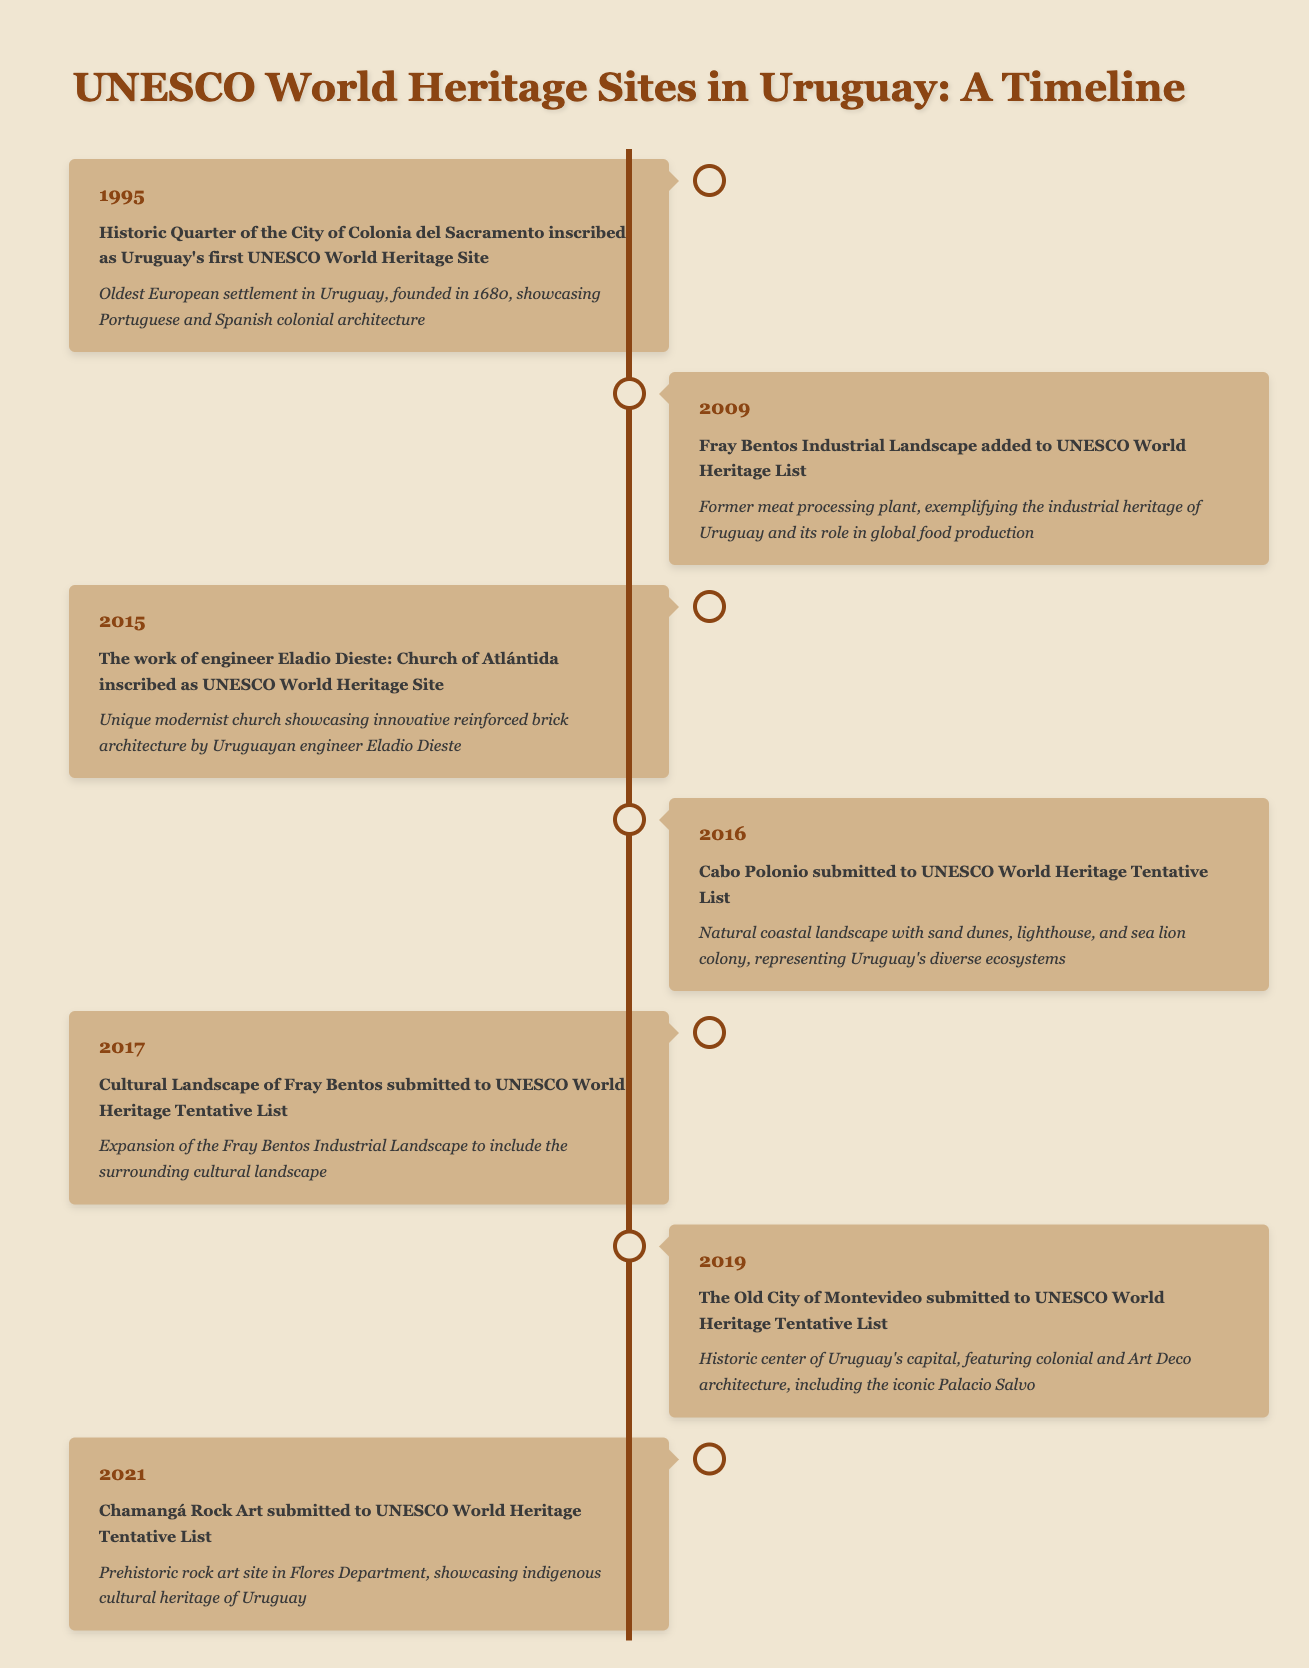What year was the Historic Quarter of the City of Colonia del Sacramento inscribed as a UNESCO World Heritage Site? According to the table, the event for the Historic Quarter of the City of Colonia del Sacramento is listed under the year 1995.
Answer: 1995 How many UNESCO World Heritage Sites were designated in the years 2009 and 2015 combined? From the table, there are two events in 2009 (Fray Bentos Industrial Landscape) and one event in 2015 (Church of Atlántida). Therefore, the total is 2 + 1 = 3.
Answer: 3 Was the work of engineer Eladio Dieste recognized as a UNESCO World Heritage Site in 2015? Yes, the table states that in 2015, the work of engineer Eladio Dieste, specifically the Church of Atlántida, was inscribed as a UNESCO World Heritage Site.
Answer: Yes Which site was added to the UNESCO World Heritage List first: Fray Bentos Industrial Landscape or the work of engineer Eladio Dieste? The table shows that the Fray Bentos Industrial Landscape was added in 2009, while the work of engineer Eladio Dieste was inscribed in 2015. Since 2009 is earlier than 2015, Fray Bentos Industrial Landscape was the first.
Answer: Fray Bentos Industrial Landscape What is the significance of Cabo Polonio as mentioned in the timeline? The table highlights that Cabo Polonio is noted for its natural coastal landscape, including sand dunes and a lighthouse, representing Uruguay's diverse ecosystems.
Answer: Natural coastal landscape representing diverse ecosystems How many UNESCO World Heritage Sites in total have submitted to the Tentative List from 2016 to 2021? The events recorded from 2016 to 2021 that are submitted to the Tentative List include Cabo Polonio (2016), Cultural Landscape of Fray Bentos (2017), The Old City of Montevideo (2019), and Chamangá Rock Art (2021). This adds up to 4 submissions.
Answer: 4 Is the Old City of Montevideo included as a UNESCO World Heritage Site in the timeline? No, the table indicates that the Old City of Montevideo was submitted to the UNESCO World Heritage Tentative List in 2019, but it does not state that it is officially designated as a UNESCO World Heritage Site.
Answer: No Which designation occurred last according to the timeline? Checking the years in the table, the last event recorded is from 2021, where Chamangá Rock Art was submitted to the Tentative List.
Answer: Chamangá Rock Art What is the total number of years between the first designation of UNESCO World Heritage Site in Uruguay and the last submission to the Tentative List? The first designation in 1995 and the last submission in 2021 makes the difference 2021 - 1995 = 26 years between these two events.
Answer: 26 years 